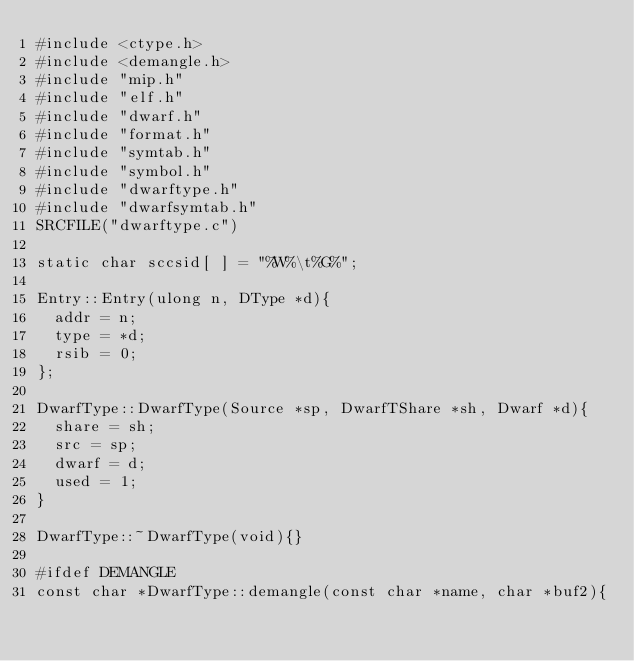<code> <loc_0><loc_0><loc_500><loc_500><_C_>#include <ctype.h>
#include <demangle.h>
#include "mip.h"
#include "elf.h"
#include "dwarf.h"
#include "format.h"
#include "symtab.h"
#include "symbol.h"
#include "dwarftype.h"
#include "dwarfsymtab.h"
SRCFILE("dwarftype.c")

static char sccsid[ ] = "%W%\t%G%";

Entry::Entry(ulong n, DType *d){
	addr = n;
	type = *d;
	rsib = 0;
};

DwarfType::DwarfType(Source *sp, DwarfTShare *sh, Dwarf *d){
	share = sh;
	src = sp;
	dwarf = d;
	used = 1;
}

DwarfType::~DwarfType(void){}

#ifdef DEMANGLE
const char *DwarfType::demangle(const char *name, char *buf2){</code> 